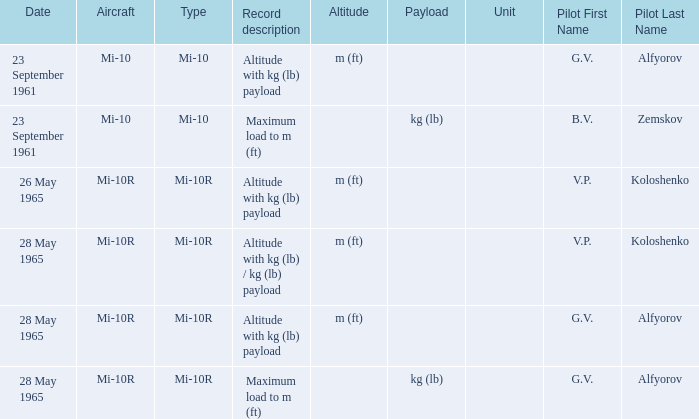Could you parse the entire table as a dict? {'header': ['Date', 'Aircraft', 'Type', 'Record description', 'Altitude', 'Payload', 'Unit', 'Pilot First Name', 'Pilot Last Name'], 'rows': [['23 September 1961', 'Mi-10', 'Mi-10', 'Altitude with kg (lb) payload', 'm (ft)', '', '', 'G.V.', 'Alfyorov'], ['23 September 1961', 'Mi-10', 'Mi-10', 'Maximum load to m (ft)', '', 'kg (lb)', '', 'B.V.', 'Zemskov'], ['26 May 1965', 'Mi-10R', 'Mi-10R', 'Altitude with kg (lb) payload', 'm (ft)', '', '', 'V.P.', 'Koloshenko'], ['28 May 1965', 'Mi-10R', 'Mi-10R', 'Altitude with kg (lb) / kg (lb) payload', 'm (ft)', '', '', 'V.P.', 'Koloshenko'], ['28 May 1965', 'Mi-10R', 'Mi-10R', 'Altitude with kg (lb) payload', 'm (ft)', '', '', 'G.V.', 'Alfyorov'], ['28 May 1965', 'Mi-10R', 'Mi-10R', 'Maximum load to m (ft)', '', 'kg (lb)', '', 'G.V.', 'Alfyorov']]} Type of mi-10r, and a Record description of altitude with kg (lb) payload, and a Pilot of g.v. alfyorov is what date? 28 May 1965. 